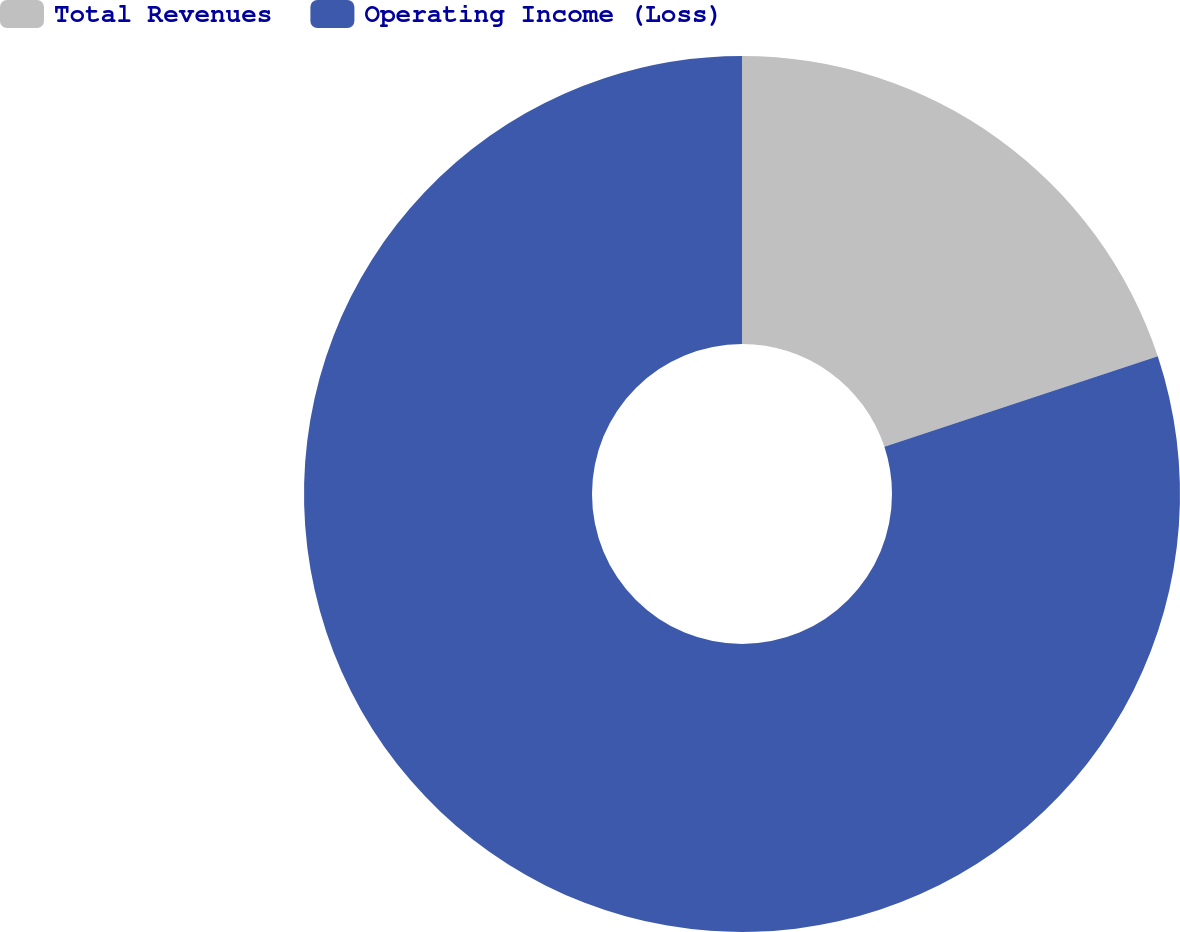<chart> <loc_0><loc_0><loc_500><loc_500><pie_chart><fcel>Total Revenues<fcel>Operating Income (Loss)<nl><fcel>19.91%<fcel>80.09%<nl></chart> 